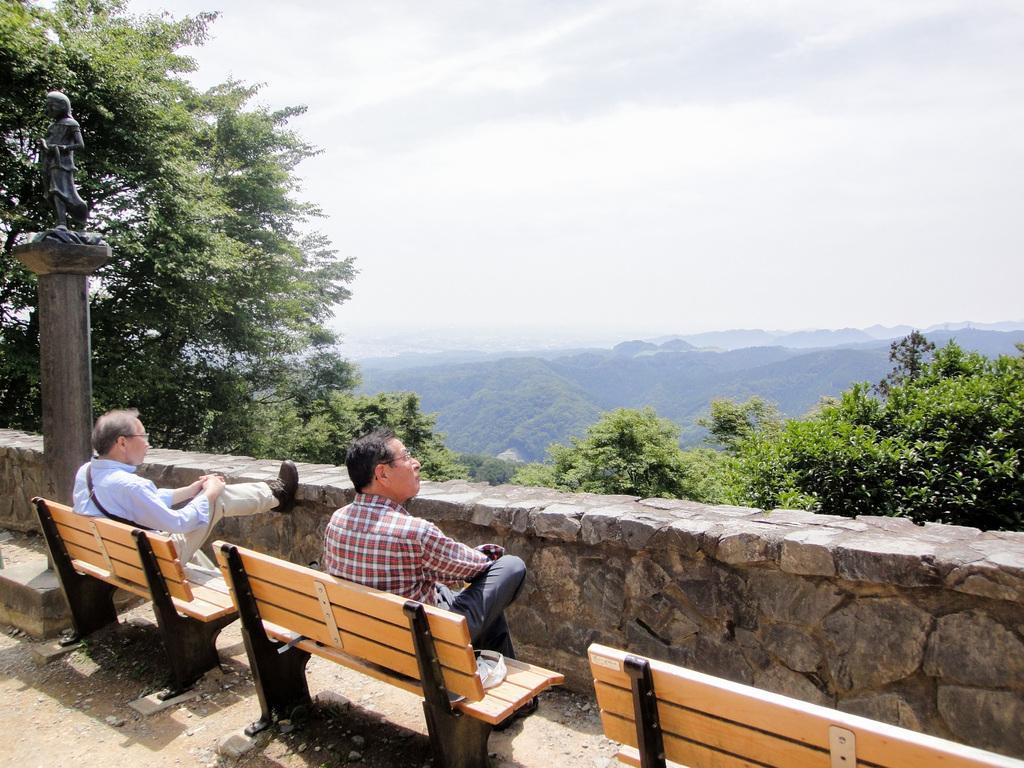Could you give a brief overview of what you see in this image? This is a picture taken in the outdoor. It is sunny. There are two people sitting on a bench. The man in white shirt on the left side there is a pillar on top of the pillar there is a statue. In front of the people there is a wall, trees, mountains and a sky. 